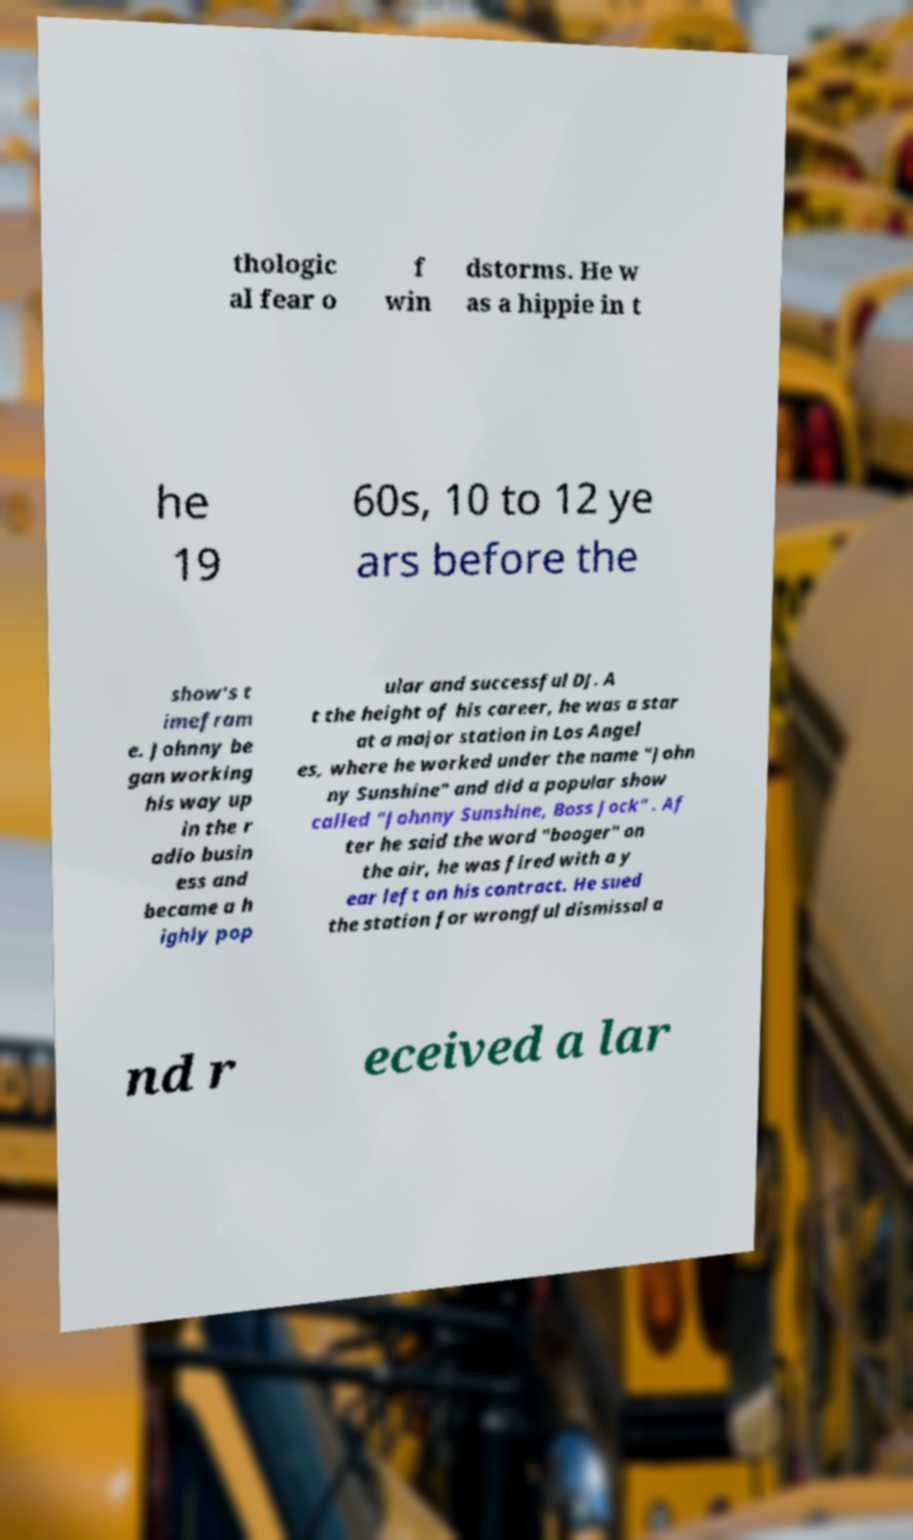Could you extract and type out the text from this image? thologic al fear o f win dstorms. He w as a hippie in t he 19 60s, 10 to 12 ye ars before the show's t imefram e. Johnny be gan working his way up in the r adio busin ess and became a h ighly pop ular and successful DJ. A t the height of his career, he was a star at a major station in Los Angel es, where he worked under the name "John ny Sunshine" and did a popular show called "Johnny Sunshine, Boss Jock" . Af ter he said the word "booger" on the air, he was fired with a y ear left on his contract. He sued the station for wrongful dismissal a nd r eceived a lar 